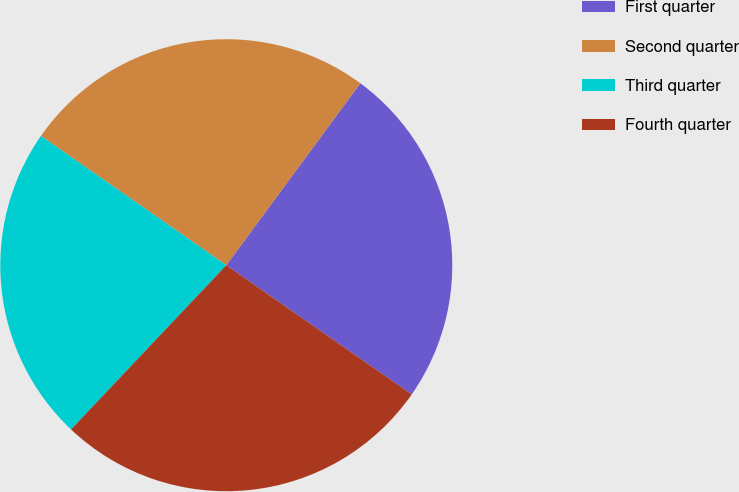Convert chart. <chart><loc_0><loc_0><loc_500><loc_500><pie_chart><fcel>First quarter<fcel>Second quarter<fcel>Third quarter<fcel>Fourth quarter<nl><fcel>24.58%<fcel>25.41%<fcel>22.64%<fcel>27.37%<nl></chart> 